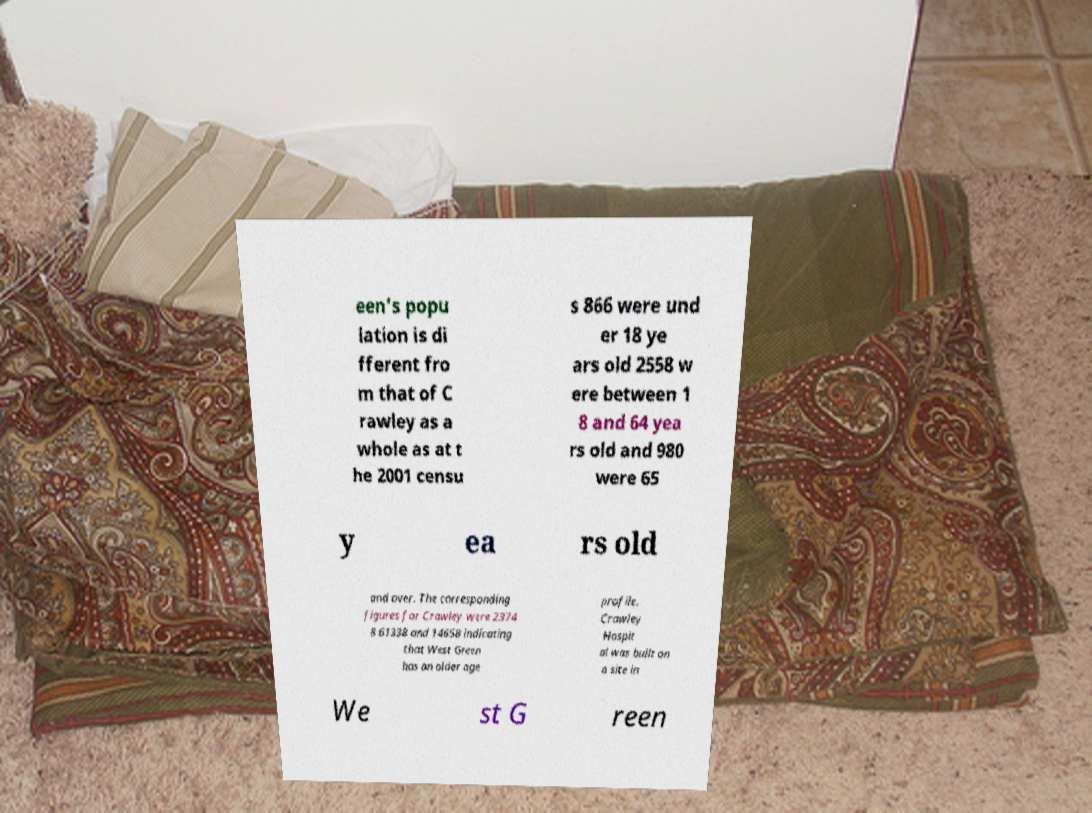There's text embedded in this image that I need extracted. Can you transcribe it verbatim? een's popu lation is di fferent fro m that of C rawley as a whole as at t he 2001 censu s 866 were und er 18 ye ars old 2558 w ere between 1 8 and 64 yea rs old and 980 were 65 y ea rs old and over. The corresponding figures for Crawley were 2374 8 61338 and 14658 indicating that West Green has an older age profile. Crawley Hospit al was built on a site in We st G reen 